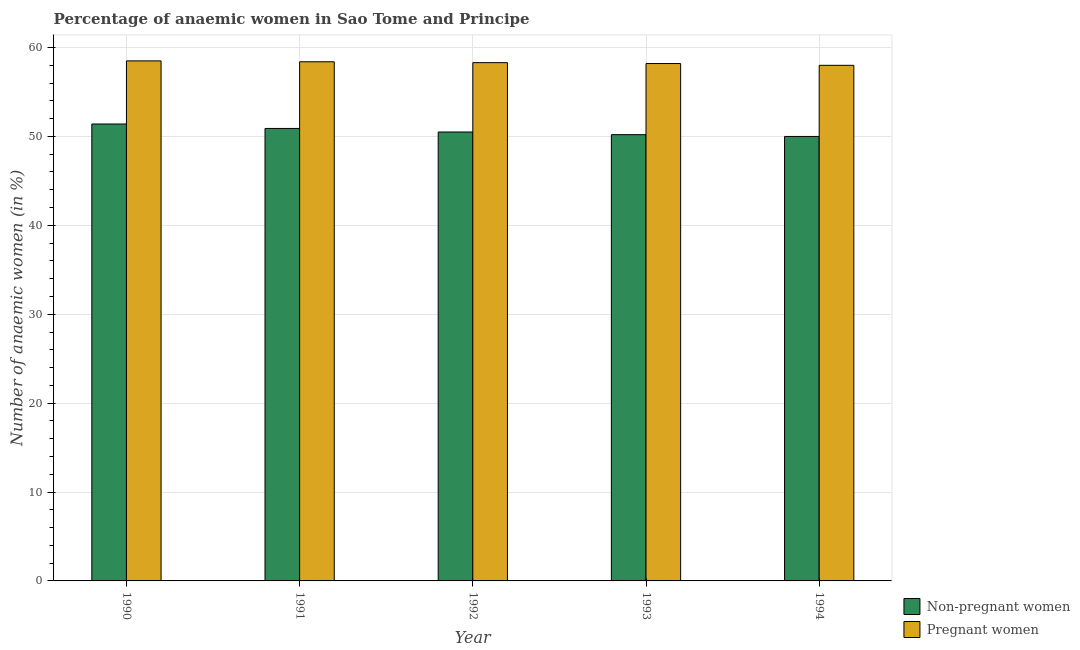How many bars are there on the 4th tick from the left?
Your answer should be very brief. 2. How many bars are there on the 1st tick from the right?
Provide a succinct answer. 2. What is the label of the 4th group of bars from the left?
Provide a succinct answer. 1993. In how many cases, is the number of bars for a given year not equal to the number of legend labels?
Make the answer very short. 0. What is the percentage of pregnant anaemic women in 1991?
Provide a short and direct response. 58.4. Across all years, what is the maximum percentage of pregnant anaemic women?
Offer a very short reply. 58.5. In which year was the percentage of non-pregnant anaemic women minimum?
Make the answer very short. 1994. What is the total percentage of pregnant anaemic women in the graph?
Ensure brevity in your answer.  291.4. What is the difference between the percentage of non-pregnant anaemic women in 1991 and that in 1994?
Provide a short and direct response. 0.9. What is the difference between the percentage of non-pregnant anaemic women in 1990 and the percentage of pregnant anaemic women in 1994?
Keep it short and to the point. 1.4. What is the average percentage of pregnant anaemic women per year?
Provide a short and direct response. 58.28. What is the ratio of the percentage of pregnant anaemic women in 1991 to that in 1993?
Your answer should be very brief. 1. Is the difference between the percentage of non-pregnant anaemic women in 1990 and 1991 greater than the difference between the percentage of pregnant anaemic women in 1990 and 1991?
Your answer should be very brief. No. What is the difference between the highest and the second highest percentage of pregnant anaemic women?
Offer a terse response. 0.1. In how many years, is the percentage of pregnant anaemic women greater than the average percentage of pregnant anaemic women taken over all years?
Keep it short and to the point. 3. Is the sum of the percentage of non-pregnant anaemic women in 1991 and 1993 greater than the maximum percentage of pregnant anaemic women across all years?
Offer a terse response. Yes. What does the 1st bar from the left in 1990 represents?
Your answer should be compact. Non-pregnant women. What does the 1st bar from the right in 1990 represents?
Give a very brief answer. Pregnant women. Are all the bars in the graph horizontal?
Provide a succinct answer. No. How many years are there in the graph?
Your answer should be compact. 5. Does the graph contain any zero values?
Provide a succinct answer. No. What is the title of the graph?
Offer a very short reply. Percentage of anaemic women in Sao Tome and Principe. What is the label or title of the X-axis?
Give a very brief answer. Year. What is the label or title of the Y-axis?
Provide a short and direct response. Number of anaemic women (in %). What is the Number of anaemic women (in %) in Non-pregnant women in 1990?
Offer a terse response. 51.4. What is the Number of anaemic women (in %) in Pregnant women in 1990?
Offer a very short reply. 58.5. What is the Number of anaemic women (in %) of Non-pregnant women in 1991?
Your response must be concise. 50.9. What is the Number of anaemic women (in %) in Pregnant women in 1991?
Keep it short and to the point. 58.4. What is the Number of anaemic women (in %) in Non-pregnant women in 1992?
Your answer should be compact. 50.5. What is the Number of anaemic women (in %) of Pregnant women in 1992?
Offer a very short reply. 58.3. What is the Number of anaemic women (in %) of Non-pregnant women in 1993?
Provide a short and direct response. 50.2. What is the Number of anaemic women (in %) in Pregnant women in 1993?
Offer a very short reply. 58.2. What is the Number of anaemic women (in %) in Non-pregnant women in 1994?
Provide a short and direct response. 50. Across all years, what is the maximum Number of anaemic women (in %) of Non-pregnant women?
Keep it short and to the point. 51.4. Across all years, what is the maximum Number of anaemic women (in %) of Pregnant women?
Your response must be concise. 58.5. What is the total Number of anaemic women (in %) in Non-pregnant women in the graph?
Give a very brief answer. 253. What is the total Number of anaemic women (in %) in Pregnant women in the graph?
Your answer should be compact. 291.4. What is the difference between the Number of anaemic women (in %) in Pregnant women in 1990 and that in 1991?
Keep it short and to the point. 0.1. What is the difference between the Number of anaemic women (in %) of Pregnant women in 1990 and that in 1993?
Keep it short and to the point. 0.3. What is the difference between the Number of anaemic women (in %) of Non-pregnant women in 1990 and that in 1994?
Offer a very short reply. 1.4. What is the difference between the Number of anaemic women (in %) of Non-pregnant women in 1991 and that in 1993?
Make the answer very short. 0.7. What is the difference between the Number of anaemic women (in %) in Pregnant women in 1992 and that in 1994?
Your answer should be compact. 0.3. What is the difference between the Number of anaemic women (in %) of Non-pregnant women in 1993 and that in 1994?
Your answer should be very brief. 0.2. What is the difference between the Number of anaemic women (in %) in Non-pregnant women in 1990 and the Number of anaemic women (in %) in Pregnant women in 1992?
Make the answer very short. -6.9. What is the difference between the Number of anaemic women (in %) in Non-pregnant women in 1990 and the Number of anaemic women (in %) in Pregnant women in 1994?
Keep it short and to the point. -6.6. What is the difference between the Number of anaemic women (in %) in Non-pregnant women in 1991 and the Number of anaemic women (in %) in Pregnant women in 1992?
Your answer should be compact. -7.4. What is the difference between the Number of anaemic women (in %) in Non-pregnant women in 1992 and the Number of anaemic women (in %) in Pregnant women in 1993?
Your response must be concise. -7.7. What is the average Number of anaemic women (in %) of Non-pregnant women per year?
Offer a terse response. 50.6. What is the average Number of anaemic women (in %) of Pregnant women per year?
Your answer should be very brief. 58.28. In the year 1991, what is the difference between the Number of anaemic women (in %) in Non-pregnant women and Number of anaemic women (in %) in Pregnant women?
Ensure brevity in your answer.  -7.5. In the year 1992, what is the difference between the Number of anaemic women (in %) of Non-pregnant women and Number of anaemic women (in %) of Pregnant women?
Your answer should be very brief. -7.8. In the year 1994, what is the difference between the Number of anaemic women (in %) of Non-pregnant women and Number of anaemic women (in %) of Pregnant women?
Provide a short and direct response. -8. What is the ratio of the Number of anaemic women (in %) of Non-pregnant women in 1990 to that in 1991?
Your answer should be very brief. 1.01. What is the ratio of the Number of anaemic women (in %) in Pregnant women in 1990 to that in 1991?
Ensure brevity in your answer.  1. What is the ratio of the Number of anaemic women (in %) of Non-pregnant women in 1990 to that in 1992?
Your answer should be very brief. 1.02. What is the ratio of the Number of anaemic women (in %) of Pregnant women in 1990 to that in 1992?
Offer a terse response. 1. What is the ratio of the Number of anaemic women (in %) of Non-pregnant women in 1990 to that in 1993?
Offer a terse response. 1.02. What is the ratio of the Number of anaemic women (in %) of Pregnant women in 1990 to that in 1993?
Offer a very short reply. 1.01. What is the ratio of the Number of anaemic women (in %) in Non-pregnant women in 1990 to that in 1994?
Your answer should be very brief. 1.03. What is the ratio of the Number of anaemic women (in %) in Pregnant women in 1990 to that in 1994?
Provide a succinct answer. 1.01. What is the ratio of the Number of anaemic women (in %) of Non-pregnant women in 1991 to that in 1992?
Your answer should be very brief. 1.01. What is the ratio of the Number of anaemic women (in %) in Pregnant women in 1991 to that in 1992?
Your response must be concise. 1. What is the ratio of the Number of anaemic women (in %) of Non-pregnant women in 1991 to that in 1993?
Provide a short and direct response. 1.01. What is the ratio of the Number of anaemic women (in %) in Non-pregnant women in 1991 to that in 1994?
Give a very brief answer. 1.02. What is the ratio of the Number of anaemic women (in %) in Non-pregnant women in 1992 to that in 1994?
Provide a succinct answer. 1.01. What is the ratio of the Number of anaemic women (in %) of Pregnant women in 1992 to that in 1994?
Provide a succinct answer. 1.01. What is the difference between the highest and the second highest Number of anaemic women (in %) in Non-pregnant women?
Provide a short and direct response. 0.5. What is the difference between the highest and the second highest Number of anaemic women (in %) of Pregnant women?
Provide a succinct answer. 0.1. What is the difference between the highest and the lowest Number of anaemic women (in %) in Non-pregnant women?
Make the answer very short. 1.4. What is the difference between the highest and the lowest Number of anaemic women (in %) in Pregnant women?
Offer a terse response. 0.5. 